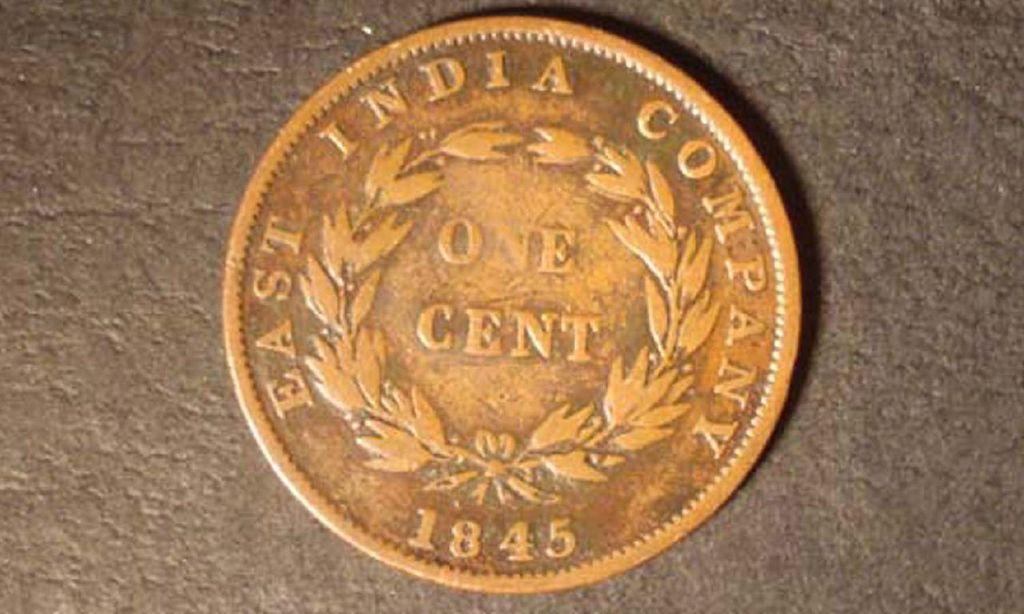<image>
Share a concise interpretation of the image provided. A copper One Cent penny that is dated1845. 